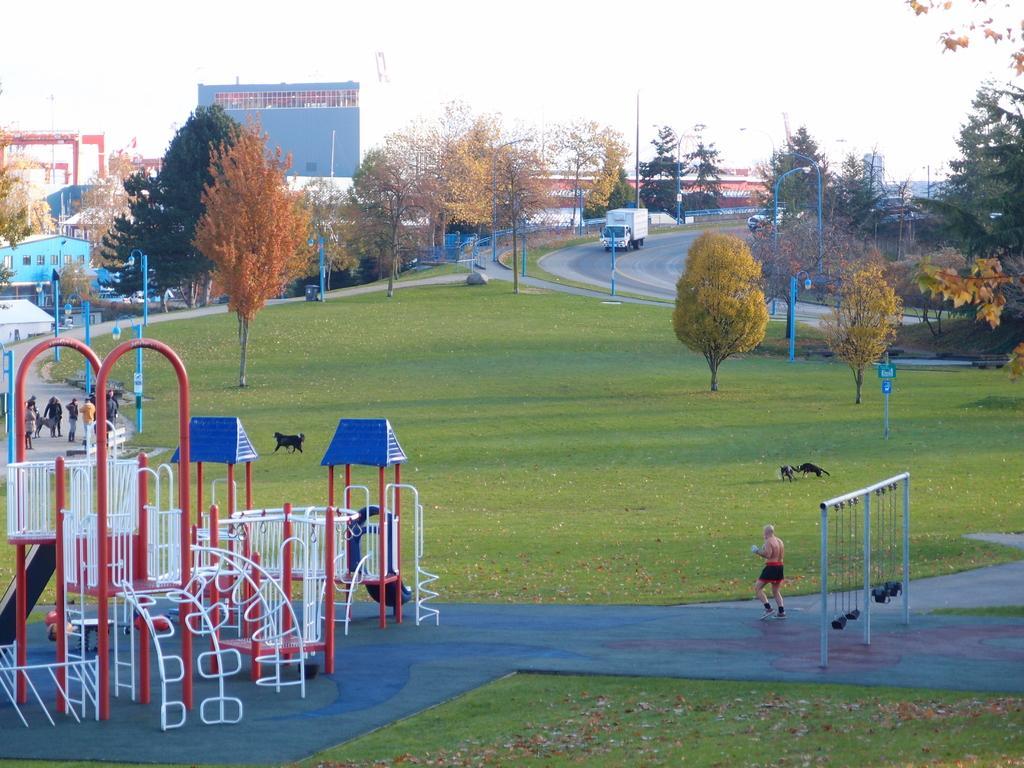Can you describe this image briefly? In this image we can see many playing objects. There are many trees in the image. There are many people in the image. There are few animals in the image. There is a grassy land in the image. There are few vehicles on the road. There is a sky in the image. 